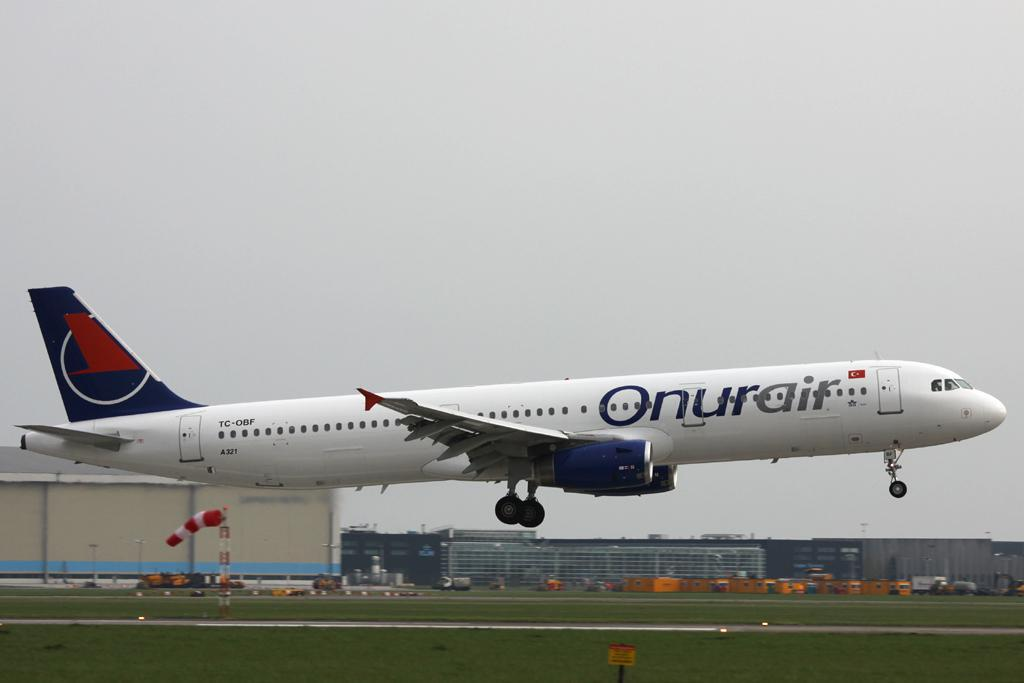<image>
Offer a succinct explanation of the picture presented. An Onur Air plane about to land on a runway 